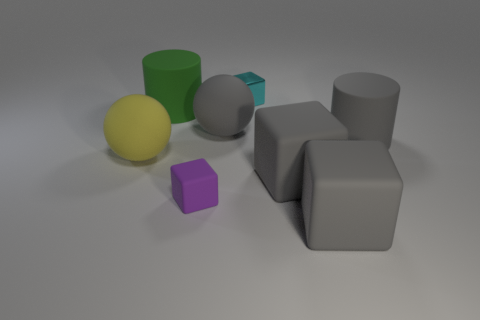Subtract all tiny purple cubes. How many cubes are left? 3 Subtract all brown cylinders. How many gray blocks are left? 2 Add 2 tiny purple objects. How many objects exist? 10 Subtract all purple blocks. How many blocks are left? 3 Subtract all brown cubes. Subtract all purple balls. How many cubes are left? 4 Subtract all cylinders. How many objects are left? 6 Add 7 small gray balls. How many small gray balls exist? 7 Subtract 0 brown cubes. How many objects are left? 8 Subtract all yellow objects. Subtract all cyan blocks. How many objects are left? 6 Add 7 big yellow rubber spheres. How many big yellow rubber spheres are left? 8 